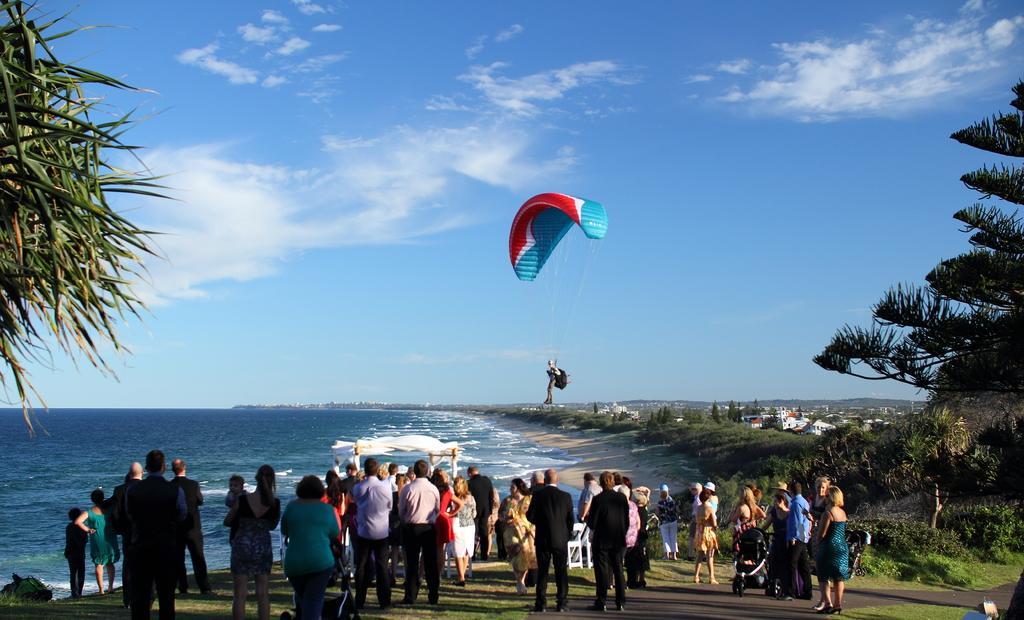How would you summarize this image in a sentence or two? In this picture we can observe some people standing. There is a person flying with the help of the parachute. There are men and women in this picture. On the left side there is an ocean. We can observe trees and some plants on the ground. In the background there is a sky with clouds. 